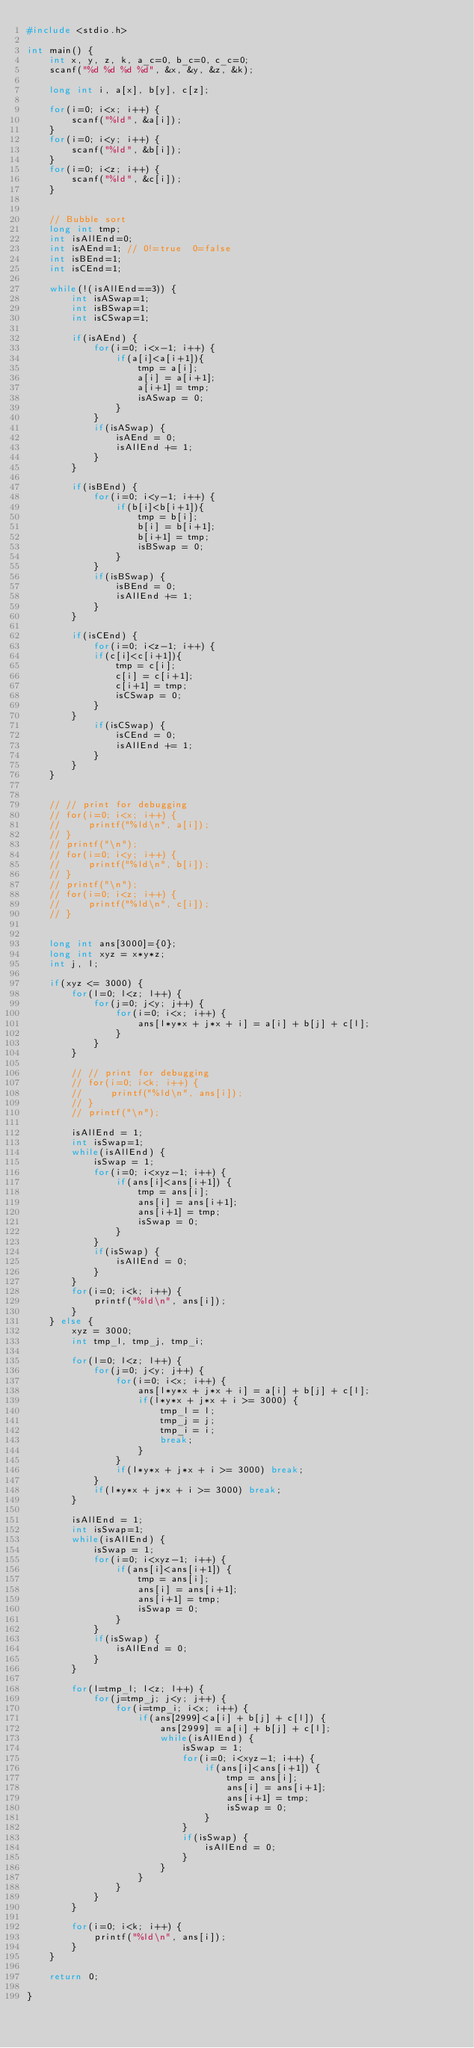<code> <loc_0><loc_0><loc_500><loc_500><_C_>#include <stdio.h>

int main() {
    int x, y, z, k, a_c=0, b_c=0, c_c=0;
    scanf("%d %d %d %d", &x, &y, &z, &k);

    long int i, a[x], b[y], c[z];

    for(i=0; i<x; i++) {
        scanf("%ld", &a[i]);
    }
    for(i=0; i<y; i++) {
        scanf("%ld", &b[i]);
    }
    for(i=0; i<z; i++) {
        scanf("%ld", &c[i]);
    }


    // Bubble sort
    long int tmp;
    int isAllEnd=0;
    int isAEnd=1; // 0!=true  0=false
    int isBEnd=1;
    int isCEnd=1;

    while(!(isAllEnd==3)) {
        int isASwap=1;
        int isBSwap=1;
        int isCSwap=1;

        if(isAEnd) {
            for(i=0; i<x-1; i++) {
                if(a[i]<a[i+1]){
                    tmp = a[i];
                    a[i] = a[i+1];
                    a[i+1] = tmp;
                    isASwap = 0;
                }
            }
            if(isASwap) {
                isAEnd = 0;
                isAllEnd += 1;
            }
        }

        if(isBEnd) {
            for(i=0; i<y-1; i++) {
                if(b[i]<b[i+1]){
                    tmp = b[i];
                    b[i] = b[i+1];
                    b[i+1] = tmp;
                    isBSwap = 0;
                }
            }
            if(isBSwap) {
                isBEnd = 0;
                isAllEnd += 1;
            }
        }

        if(isCEnd) {
            for(i=0; i<z-1; i++) {
            if(c[i]<c[i+1]){
                tmp = c[i];
                c[i] = c[i+1];
                c[i+1] = tmp;
                isCSwap = 0;
            }
        }
            if(isCSwap) {
                isCEnd = 0;
                isAllEnd += 1;
            }
        }
    }


    // // print for debugging
    // for(i=0; i<x; i++) {
    //     printf("%ld\n", a[i]);
    // }
    // printf("\n");
    // for(i=0; i<y; i++) {
    //     printf("%ld\n", b[i]);
    // }
    // printf("\n");
    // for(i=0; i<z; i++) {
    //     printf("%ld\n", c[i]);
    // }


    long int ans[3000]={0};
    long int xyz = x*y*z;
    int j, l;

    if(xyz <= 3000) {
        for(l=0; l<z; l++) {
            for(j=0; j<y; j++) {
                for(i=0; i<x; i++) {
                    ans[l*y*x + j*x + i] = a[i] + b[j] + c[l];
                }
            }
        }

        // // print for debugging
        // for(i=0; i<k; i++) {
        //     printf("%ld\n", ans[i]);
        // }
        // printf("\n");

        isAllEnd = 1;
        int isSwap=1;
        while(isAllEnd) {
            isSwap = 1;
            for(i=0; i<xyz-1; i++) {
                if(ans[i]<ans[i+1]) {
                    tmp = ans[i];
                    ans[i] = ans[i+1];
                    ans[i+1] = tmp;
                    isSwap = 0;
                }
            }
            if(isSwap) {
                isAllEnd = 0;
            }
        }
        for(i=0; i<k; i++) {
            printf("%ld\n", ans[i]);
        }
    } else {
        xyz = 3000;
        int tmp_l, tmp_j, tmp_i;

        for(l=0; l<z; l++) {
            for(j=0; j<y; j++) {
                for(i=0; i<x; i++) {
                    ans[l*y*x + j*x + i] = a[i] + b[j] + c[l];
                    if(l*y*x + j*x + i >= 3000) {
                        tmp_l = l;
                        tmp_j = j;
                        tmp_i = i;
                        break;
                    }
                }
                if(l*y*x + j*x + i >= 3000) break;
            }
            if(l*y*x + j*x + i >= 3000) break;
        }

        isAllEnd = 1;
        int isSwap=1;
        while(isAllEnd) {
            isSwap = 1;
            for(i=0; i<xyz-1; i++) {
                if(ans[i]<ans[i+1]) {
                    tmp = ans[i];
                    ans[i] = ans[i+1];
                    ans[i+1] = tmp;
                    isSwap = 0;
                }
            }
            if(isSwap) {
                isAllEnd = 0;
            }
        }

        for(l=tmp_l; l<z; l++) {
            for(j=tmp_j; j<y; j++) {
                for(i=tmp_i; i<x; i++) {
                    if(ans[2999]<a[i] + b[j] + c[l]) {
                        ans[2999] = a[i] + b[j] + c[l];
                        while(isAllEnd) {
                            isSwap = 1;
                            for(i=0; i<xyz-1; i++) {
                                if(ans[i]<ans[i+1]) {
                                    tmp = ans[i];
                                    ans[i] = ans[i+1];
                                    ans[i+1] = tmp;
                                    isSwap = 0;
                                }
                            }
                            if(isSwap) {
                                isAllEnd = 0;
                            }
                        }
                    }
                }
            }
        }

        for(i=0; i<k; i++) {
            printf("%ld\n", ans[i]);
        }
    }

    return 0;

}</code> 